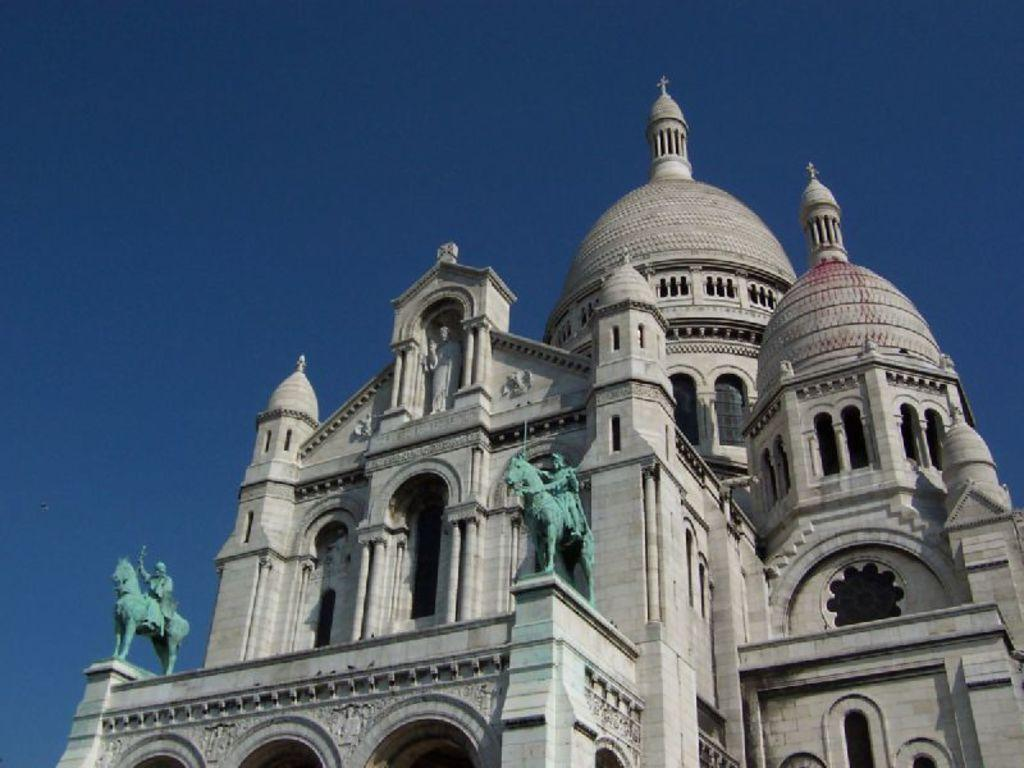What type of architectural feature can be seen in the image? There is a building with arches in the image. What structural elements support the building? The building has pillars. Are there any decorative elements on the building? Yes, there are statues on the building. What can be seen in the background of the image? The sky is visible in the background of the image. How many times does the lumber appear in the image? There is no lumber present in the image. What part of the body is the statue using to bite in the image? There are no statues biting anything in the image. 